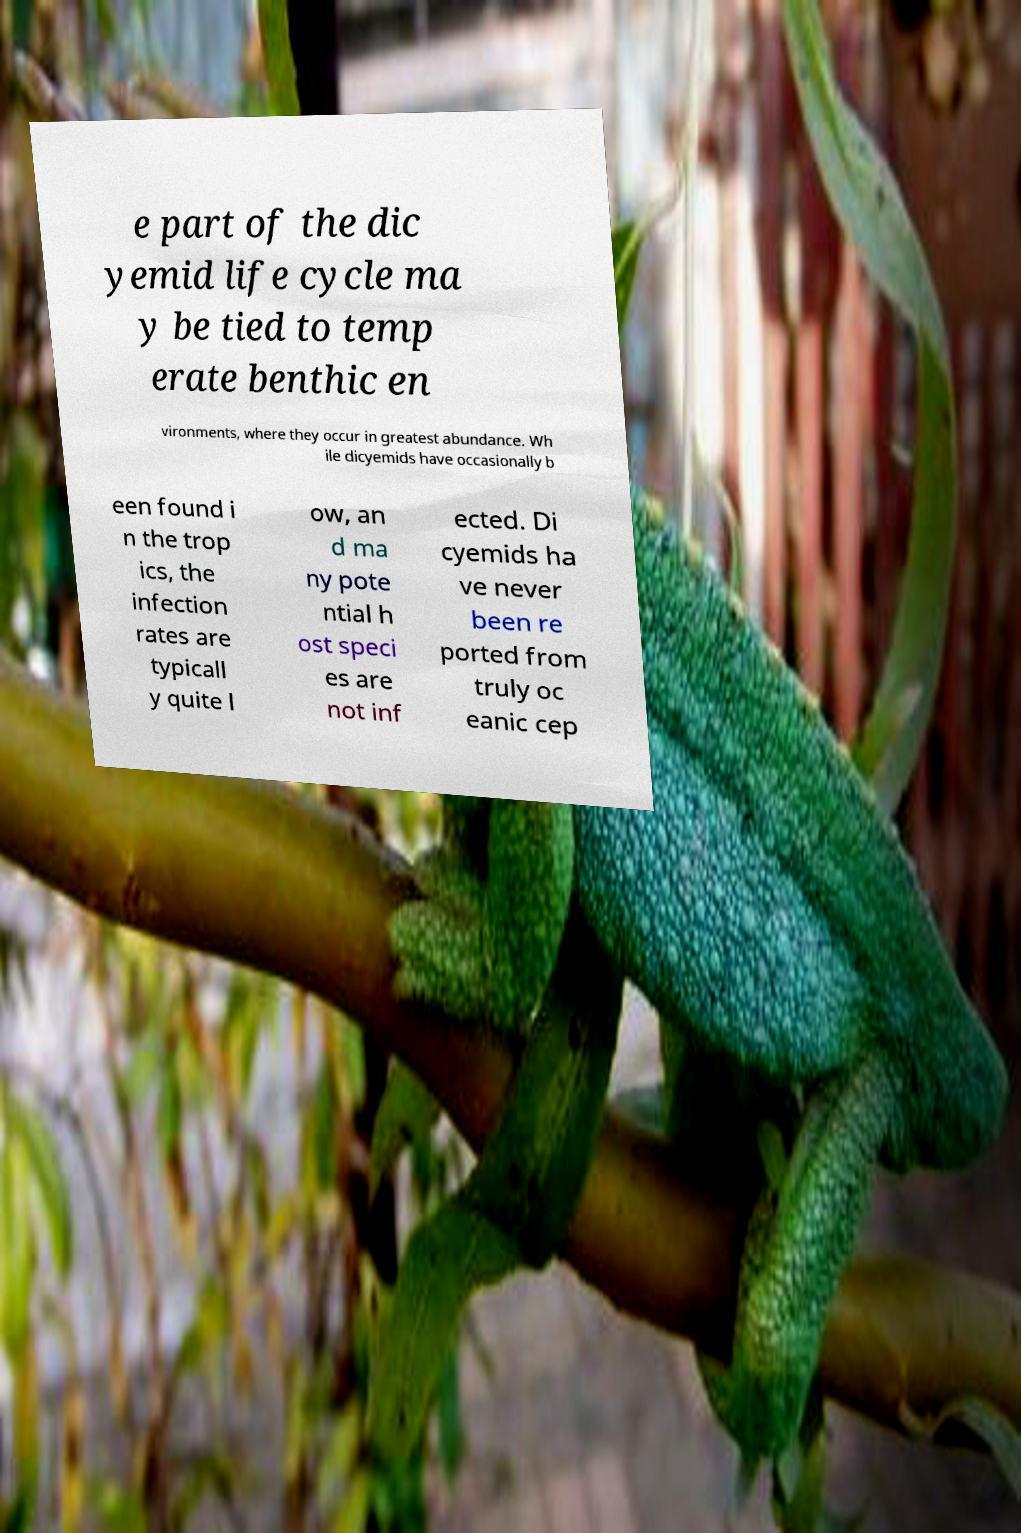Could you extract and type out the text from this image? e part of the dic yemid life cycle ma y be tied to temp erate benthic en vironments, where they occur in greatest abundance. Wh ile dicyemids have occasionally b een found i n the trop ics, the infection rates are typicall y quite l ow, an d ma ny pote ntial h ost speci es are not inf ected. Di cyemids ha ve never been re ported from truly oc eanic cep 